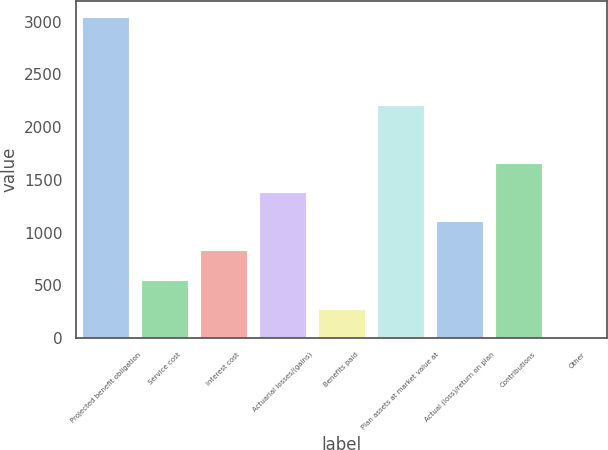<chart> <loc_0><loc_0><loc_500><loc_500><bar_chart><fcel>Projected benefit obligation<fcel>Service cost<fcel>Interest cost<fcel>Actuarial losses/(gains)<fcel>Benefits paid<fcel>Plan assets at market value at<fcel>Actual (loss)/return on plan<fcel>Contributions<fcel>Other<nl><fcel>3043.6<fcel>554.2<fcel>830.8<fcel>1384<fcel>277.6<fcel>2213.8<fcel>1107.4<fcel>1660.6<fcel>1<nl></chart> 